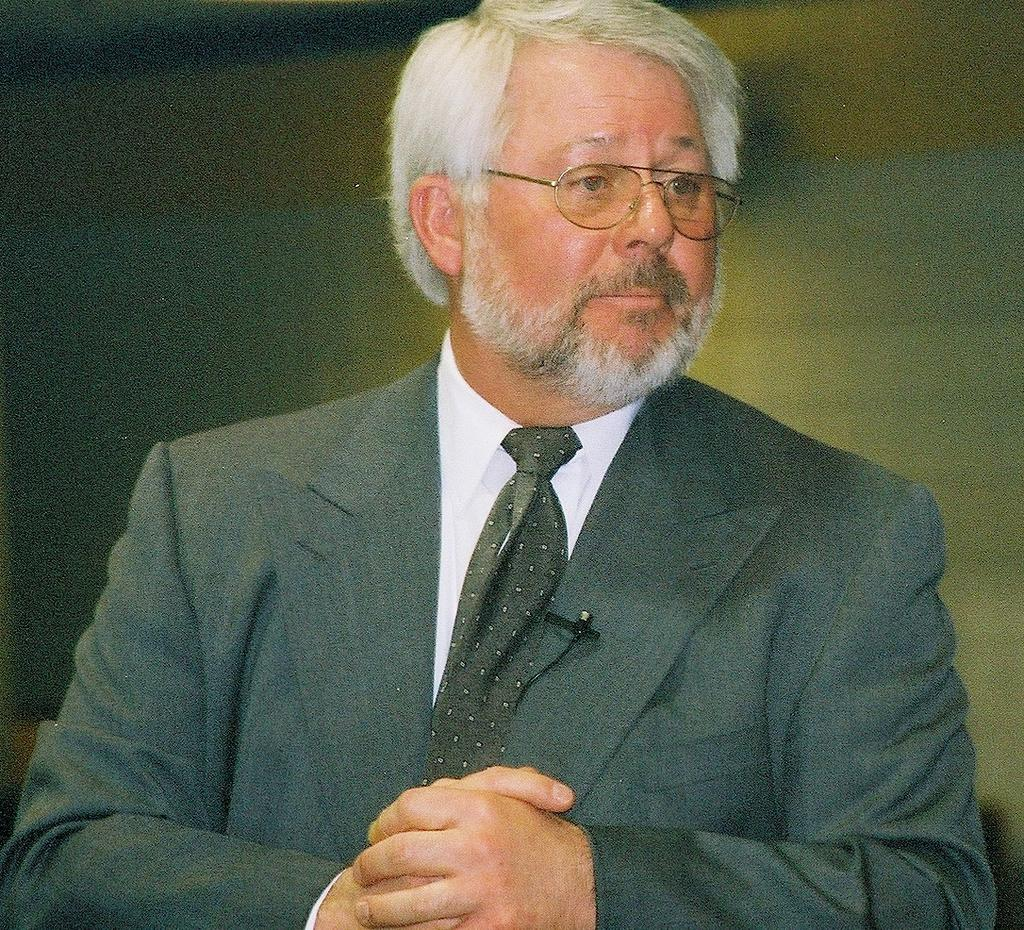What is the main subject of the image? The main subject of the image is a man. In which direction is the man looking? The man is looking to the right. What type of clothing is the man wearing? The man is wearing a blazer, a tie, and a shirt. Can you describe the man's appearance? The man has white hair and a white beard. What type of frame is visible in the image? There is no frame present in the image; it features a man looking to the right while wearing a blazer, tie, and shirt, with white hair and a white beard. 